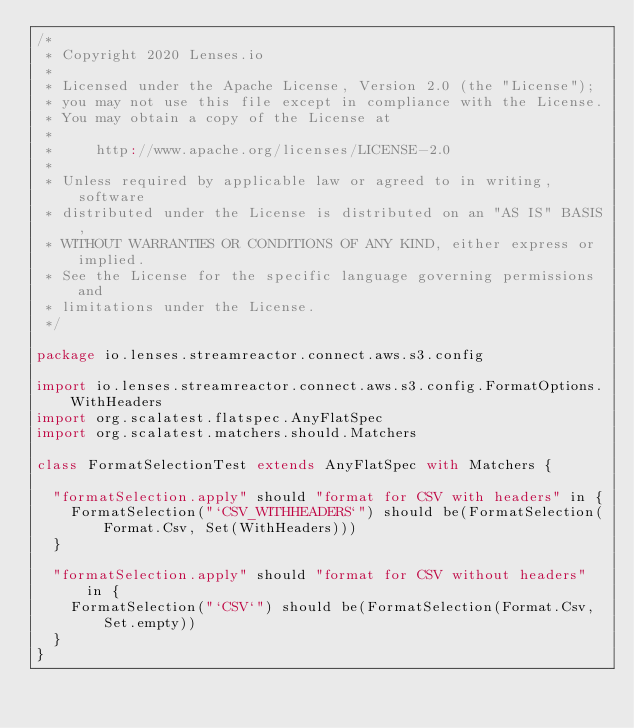Convert code to text. <code><loc_0><loc_0><loc_500><loc_500><_Scala_>/*
 * Copyright 2020 Lenses.io
 *
 * Licensed under the Apache License, Version 2.0 (the "License");
 * you may not use this file except in compliance with the License.
 * You may obtain a copy of the License at
 *
 *     http://www.apache.org/licenses/LICENSE-2.0
 *
 * Unless required by applicable law or agreed to in writing, software
 * distributed under the License is distributed on an "AS IS" BASIS,
 * WITHOUT WARRANTIES OR CONDITIONS OF ANY KIND, either express or implied.
 * See the License for the specific language governing permissions and
 * limitations under the License.
 */

package io.lenses.streamreactor.connect.aws.s3.config

import io.lenses.streamreactor.connect.aws.s3.config.FormatOptions.WithHeaders
import org.scalatest.flatspec.AnyFlatSpec
import org.scalatest.matchers.should.Matchers

class FormatSelectionTest extends AnyFlatSpec with Matchers {

  "formatSelection.apply" should "format for CSV with headers" in {
    FormatSelection("`CSV_WITHHEADERS`") should be(FormatSelection(Format.Csv, Set(WithHeaders)))
  }

  "formatSelection.apply" should "format for CSV without headers" in {
    FormatSelection("`CSV`") should be(FormatSelection(Format.Csv, Set.empty))
  }
}
</code> 